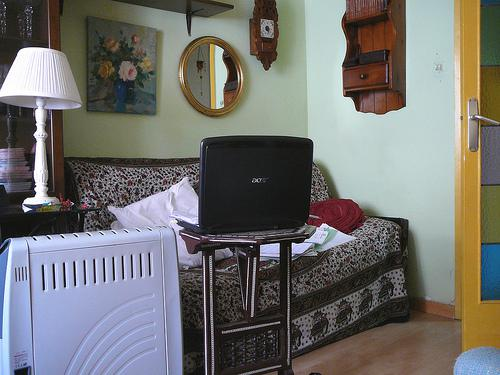Question: where is the mirror?
Choices:
A. On the door.
B. Above the sink.
C. In the bathroom.
D. On wall.
Answer with the letter. Answer: D Question: what is on the picture on the wall?
Choices:
A. Flowers in vase.
B. Mountains.
C. Ballet Dancers.
D. Cats.
Answer with the letter. Answer: A Question: what is burgundy?
Choices:
A. Couch.
B. Pillow.
C. Chairs.
D. Dishes.
Answer with the letter. Answer: B Question: who opened the door?
Choices:
A. The wind.
B. A person.
C. Automatic Opener.
D. A cat.
Answer with the letter. Answer: B Question: why is there a high table?
Choices:
A. So people can stand to use it.
B. Holding laptop.
C. To hold drinks.
D. To hold food.
Answer with the letter. Answer: B Question: what is black?
Choices:
A. Stapler.
B. Phone.
C. Tv.
D. Laptop.
Answer with the letter. Answer: D Question: how is the door?
Choices:
A. Closed.
B. Red.
C. Open.
D. Black.
Answer with the letter. Answer: C 